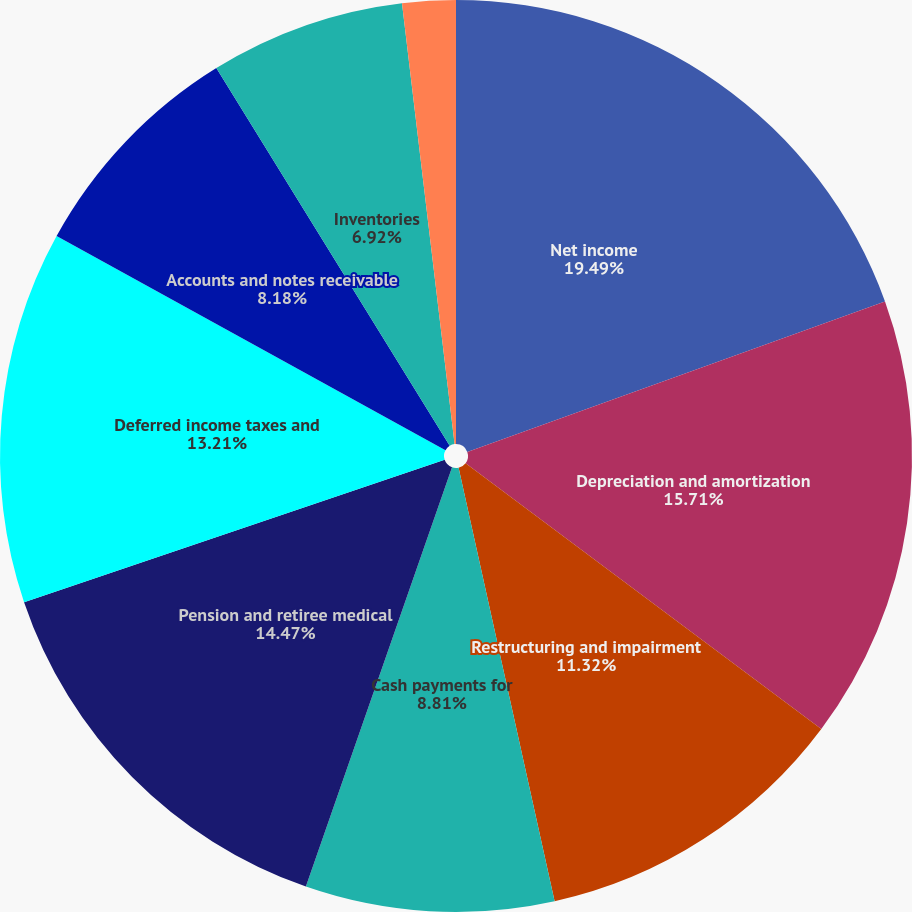Convert chart. <chart><loc_0><loc_0><loc_500><loc_500><pie_chart><fcel>Net income<fcel>Depreciation and amortization<fcel>Restructuring and impairment<fcel>Cash payments for<fcel>Pension and retiree medical<fcel>Deferred income taxes and<fcel>Accounts and notes receivable<fcel>Inventories<fcel>Prepaid expenses and other<nl><fcel>19.5%<fcel>15.72%<fcel>11.32%<fcel>8.81%<fcel>14.47%<fcel>13.21%<fcel>8.18%<fcel>6.92%<fcel>1.89%<nl></chart> 